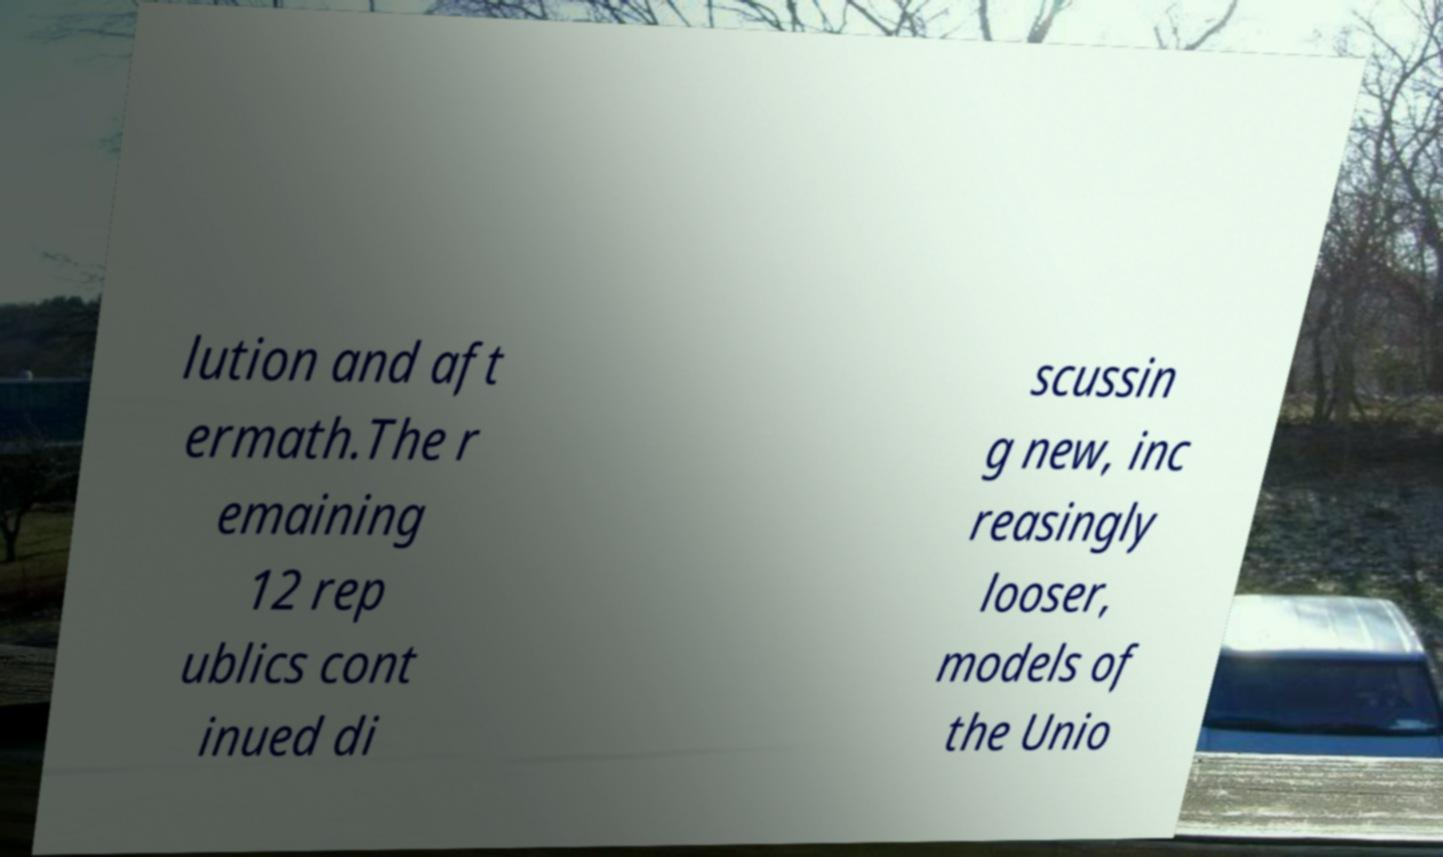Could you assist in decoding the text presented in this image and type it out clearly? lution and aft ermath.The r emaining 12 rep ublics cont inued di scussin g new, inc reasingly looser, models of the Unio 